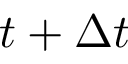Convert formula to latex. <formula><loc_0><loc_0><loc_500><loc_500>t + \Delta t</formula> 